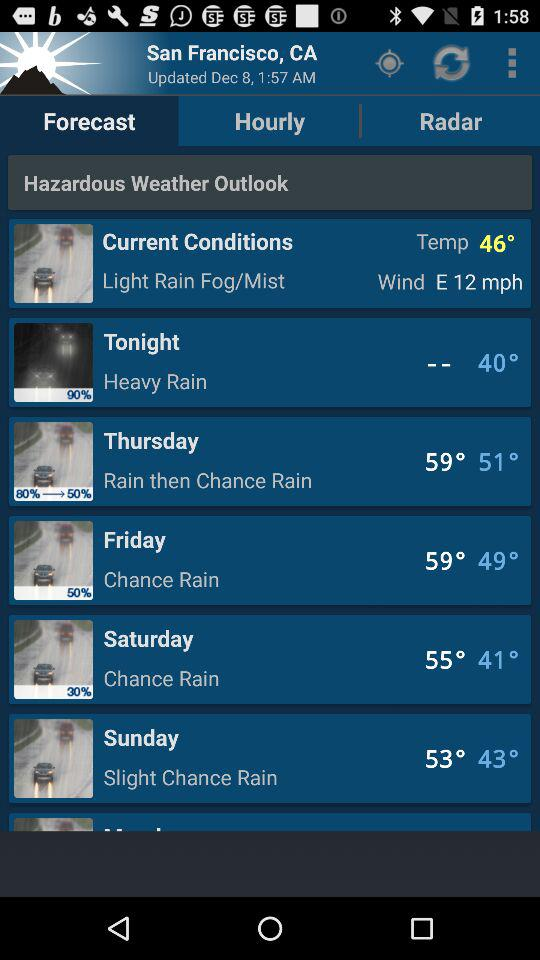What is the wind speed? The wind speed is 12 mph. 